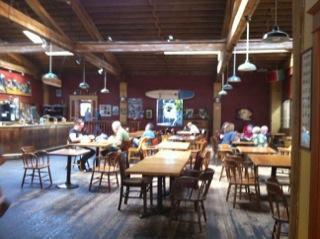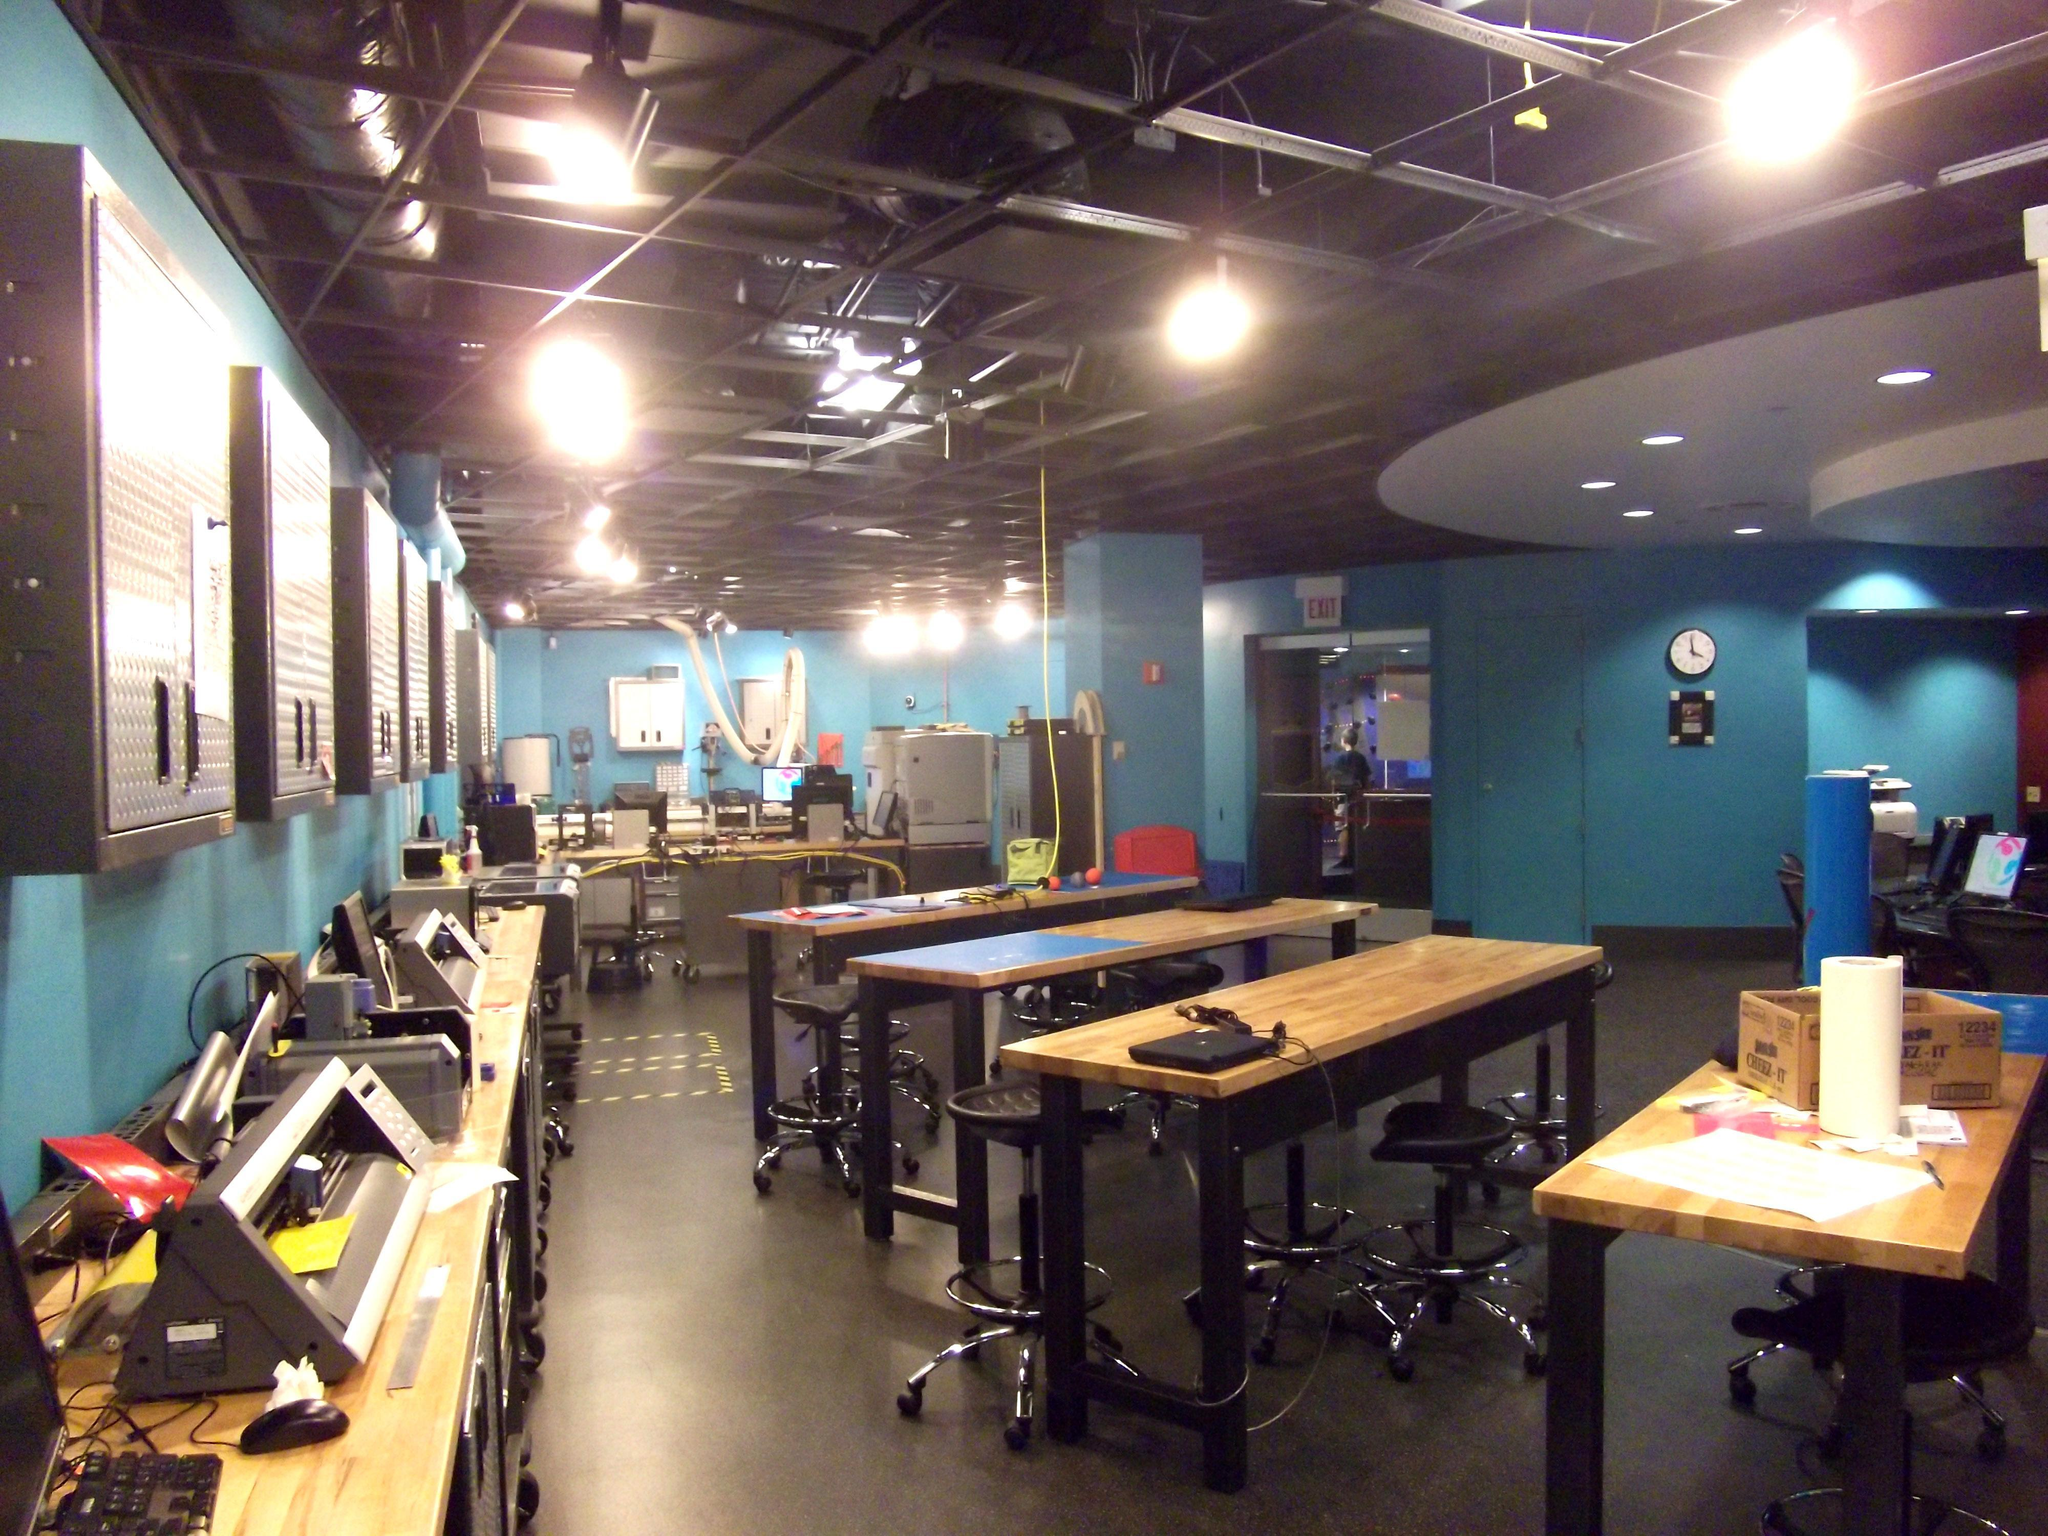The first image is the image on the left, the second image is the image on the right. Analyze the images presented: Is the assertion "Dome-shaped lights in rows suspend several feet from the ceiling over multiple seated customers in the left image." valid? Answer yes or no. Yes. The first image is the image on the left, the second image is the image on the right. For the images shown, is this caption "The room in the right image has no people in it." true? Answer yes or no. Yes. 